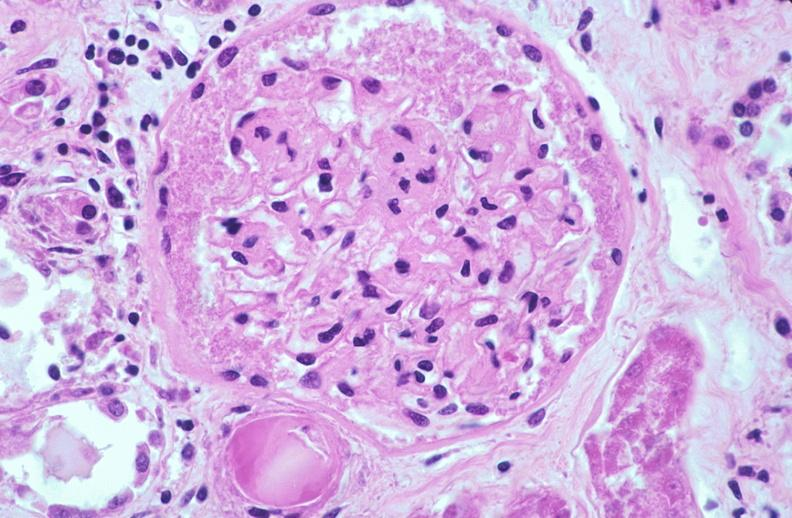where is this?
Answer the question using a single word or phrase. Urinary 